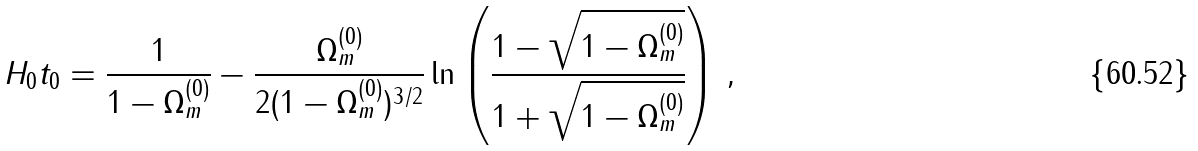Convert formula to latex. <formula><loc_0><loc_0><loc_500><loc_500>H _ { 0 } t _ { 0 } = \frac { 1 } { 1 - \Omega ^ { ( 0 ) } _ { m } } - \frac { \Omega ^ { ( 0 ) } _ { m } } { 2 ( 1 - \Omega ^ { ( 0 ) } _ { m } ) ^ { 3 / 2 } } \ln \left ( \frac { 1 - \sqrt { 1 - \Omega _ { m } ^ { ( 0 ) } } } { 1 + \sqrt { 1 - \Omega _ { m } ^ { ( 0 ) } } } \right ) \, ,</formula> 